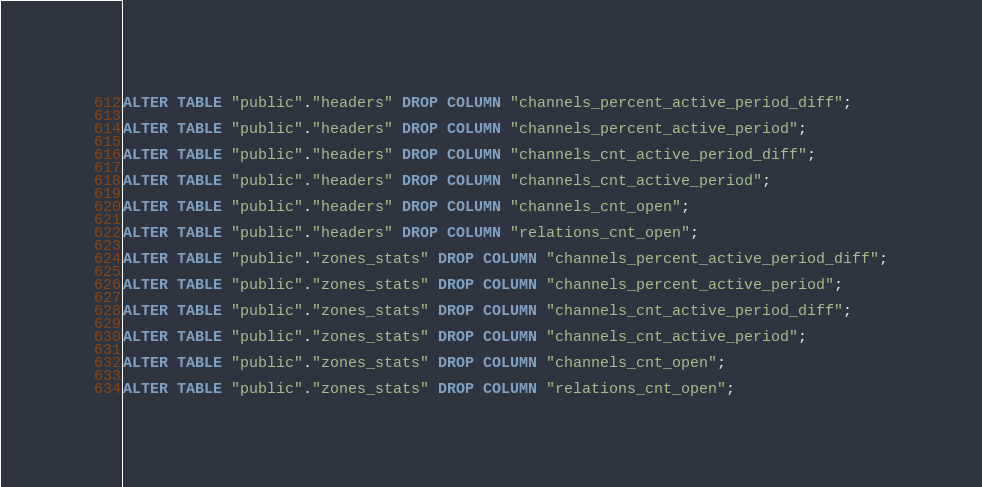<code> <loc_0><loc_0><loc_500><loc_500><_SQL_>
ALTER TABLE "public"."headers" DROP COLUMN "channels_percent_active_period_diff";

ALTER TABLE "public"."headers" DROP COLUMN "channels_percent_active_period";

ALTER TABLE "public"."headers" DROP COLUMN "channels_cnt_active_period_diff";

ALTER TABLE "public"."headers" DROP COLUMN "channels_cnt_active_period";

ALTER TABLE "public"."headers" DROP COLUMN "channels_cnt_open";

ALTER TABLE "public"."headers" DROP COLUMN "relations_cnt_open";

ALTER TABLE "public"."zones_stats" DROP COLUMN "channels_percent_active_period_diff";

ALTER TABLE "public"."zones_stats" DROP COLUMN "channels_percent_active_period";

ALTER TABLE "public"."zones_stats" DROP COLUMN "channels_cnt_active_period_diff";

ALTER TABLE "public"."zones_stats" DROP COLUMN "channels_cnt_active_period";

ALTER TABLE "public"."zones_stats" DROP COLUMN "channels_cnt_open";

ALTER TABLE "public"."zones_stats" DROP COLUMN "relations_cnt_open";
</code> 